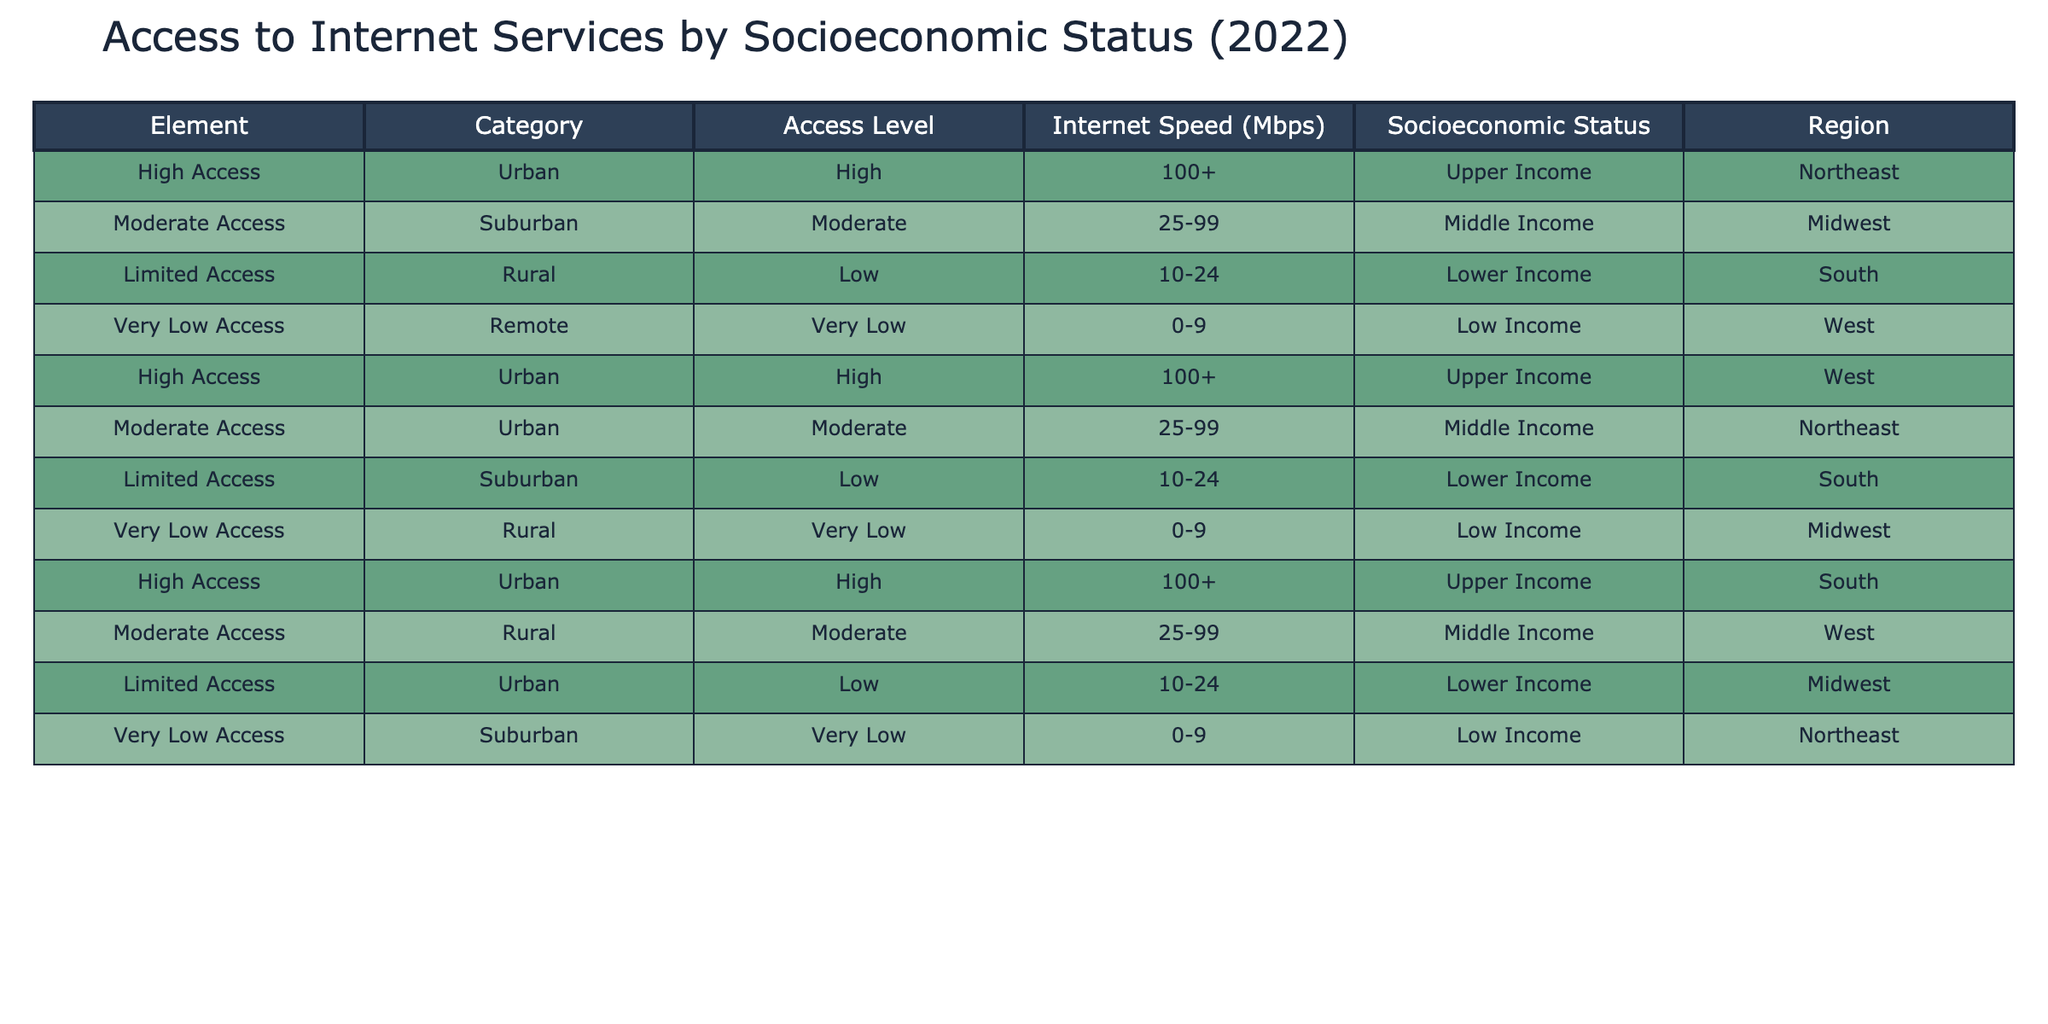What is the Internet speed range for Limited Access in Rural areas? The table shows that for Limited Access in Rural areas, the Internet speed range is 10-24 Mbps. This information can be directly retrieved from the corresponding row related to Limited Access and Rural under the Internet Speed column.
Answer: 10-24 Mbps How many categories of Internet access are listed for Middle Income households? In the table, there are two categories related to Middle Income households, which are Moderate Access in Suburban and Urban areas. This can be determined by filtering the table based on the Socioeconomic Status column and counting the distinct access levels for Middle Income.
Answer: 2 Does High Access always correspond to Upper Income households? Yes, every instance of High Access in the table corresponds to Upper Income households. In all entries with High Access, the Socioeconomic Status is consistently listed as Upper Income.
Answer: Yes What is the average Internet speed for Limited Access across all regions? Limited Access appears in three regions: Rural (10-24 Mbps), Suburban (10-24 Mbps), and Urban (10-24 Mbps). First, we consider the average of these speed ranges. Summing the minimum and maximum for each region gives (10 + 10 + 10) / 3 and (24 + 24 + 24) / 3, resulting in an average of 10 Mbps for the lower end and 24 Mbps for the upper end. Thus, the average Internet speed for Limited Access across all regions is 10-24 Mbps.
Answer: 10-24 Mbps What proportion of the total entries in the table represents Very Low Access? The table has a total of 10 entries. There are three instances of Very Low Access (Remote and Rural regions), resulting in a proportion calculated as 3 out of 10 entries. Therefore, the proportion of Very Low Access is 3/10 which simplifies to 0.3 or 30%.
Answer: 30% How many different regions are represented in the High Access category? There are three entries showing High Access in the table, corresponding to three different regions: Northeast, South, and West. Each entry can be identified by filtering the High Access category in the Region column.
Answer: 3 